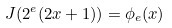<formula> <loc_0><loc_0><loc_500><loc_500>J ( 2 ^ { e } ( 2 x + 1 ) ) = \phi _ { e } ( x )</formula> 